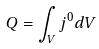<formula> <loc_0><loc_0><loc_500><loc_500>Q = \int _ { V } j ^ { 0 } d V</formula> 